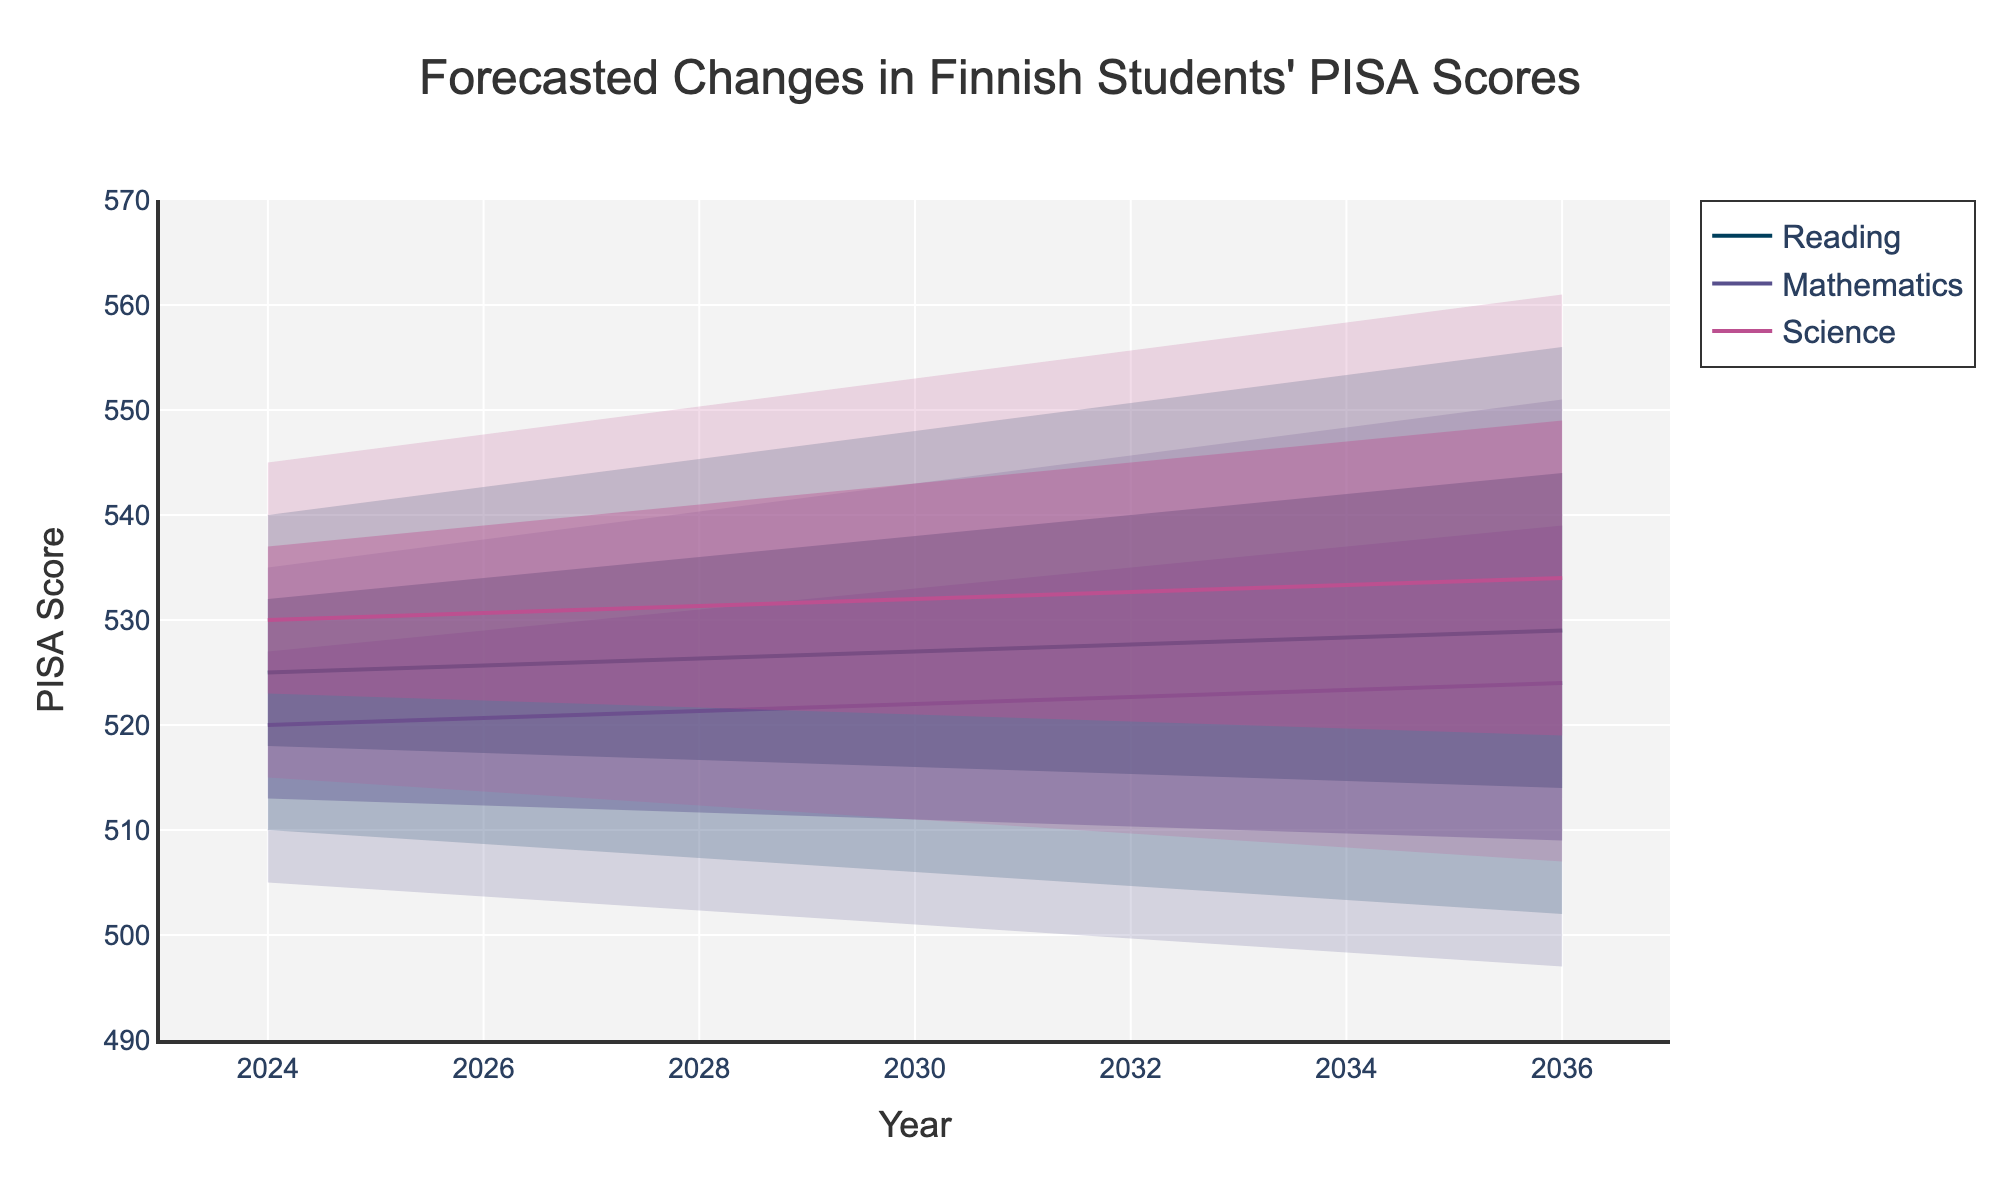What is the median PISA score forecasted in Mathematics for 2027? Locate the 'Mathematics' subject on the chart and find the median line for the year 2027. The median value is clearly marked.
Answer: 521 How do the upper bounds of PISA scores in Science change from 2024 to 2036? Look at the 'Science' section of the chart and trace the upper bound line from 2024 to 2036 to see the progression in scores
Answer: They increase from 545 to 561 Which subject shows the highest median forecasted PISA score in 2030? Compare the median lines of all subjects in the year 2030. Identify the subject with the highest median value.
Answer: Reading What is the difference between the median PISA scores in Reading and Mathematics for 2033? Find the median values for 'Reading' and 'Mathematics' in 2033, and subtract the median Mathematics value from the median Reading value.
Answer: 528 - 523 = 5 In which year does Reading show the lowest lower bound forecasted PISA score? Examine the lower bounds for 'Reading' across all years and identify the year with the lowest value.
Answer: 2036 What subject has the smallest range between the lower bound and the upper bound forecasted PISA score in 2027? Calculate the range (Upper - Lower) for all subjects in 2027 and compare them to find the smallest range.
Answer: Mathematics (32) Which subject shows the greatest increase in the median forecasted PISA score from 2024 to 2036? Analyze the median values for each subject in 2024 and 2036, and calculate the difference for each. Determine the subject with the greatest positive change.
Answer: Reading Do the median PISA scores in Science show consistent increase over the years? Observe the median line for 'Science' and check whether each subsequent year has a higher median score compared to the previous year.
Answer: Yes 